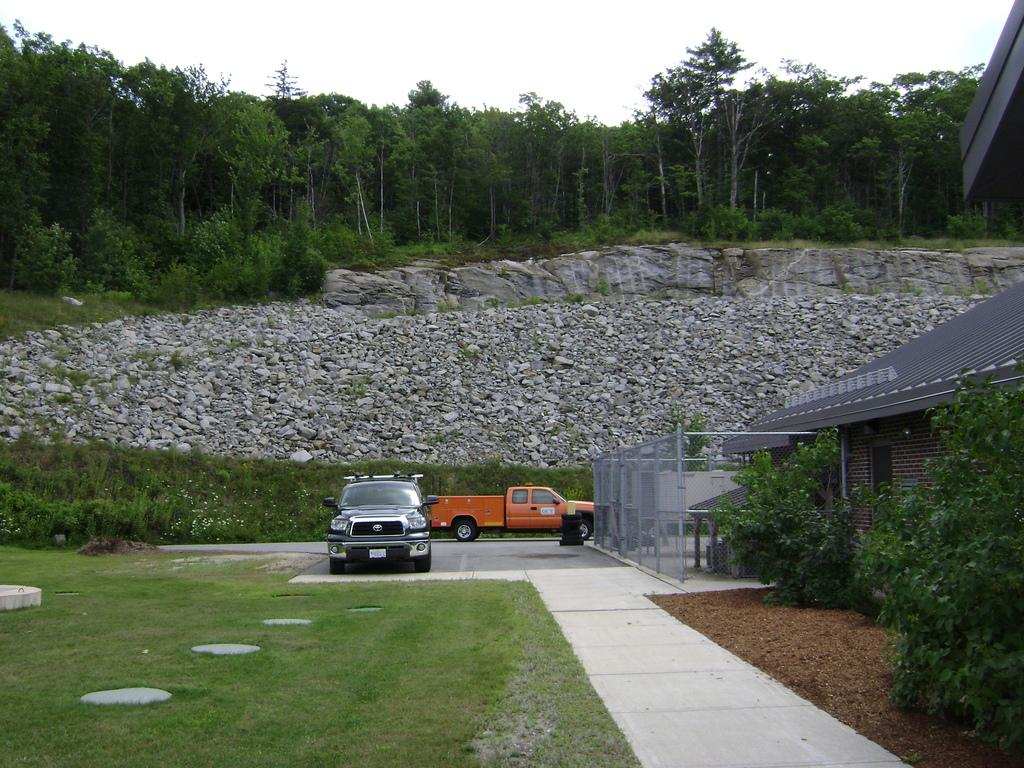What type of vehicles can be seen in the image? There are cars in the image. What is the purpose of the fence in the image? The fence serves as a barrier or boundary in the image. What type of building is present in the image? There is a house in the image. What natural elements can be seen in the background of the image? There are rocks and trees visible in the background of the image. How many beds are visible in the image? There are no beds present in the image. What type of wind can be seen in the image? There is no wind visible in the image; it is a still image. 